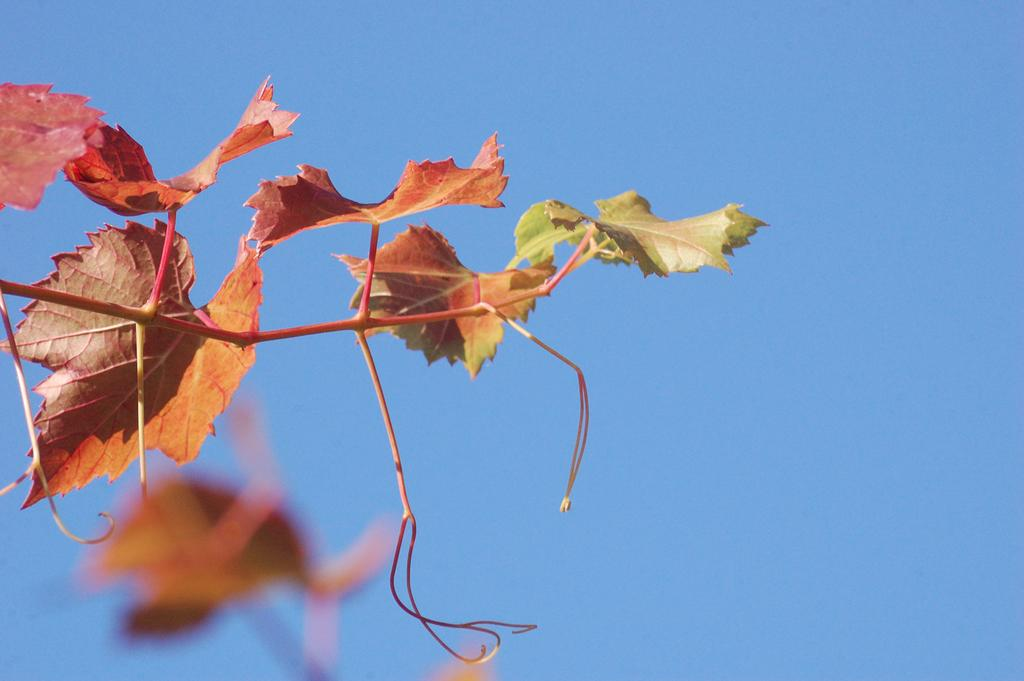What type of plant is featured in the image? There is a branch with maple leaves in the image. What can be seen in the background of the image? The sky is visible in the background of the image. What type of wine is being served to the stranger in the image? There is no wine or stranger present in the image; it features a branch with maple leaves and the sky in the background. 